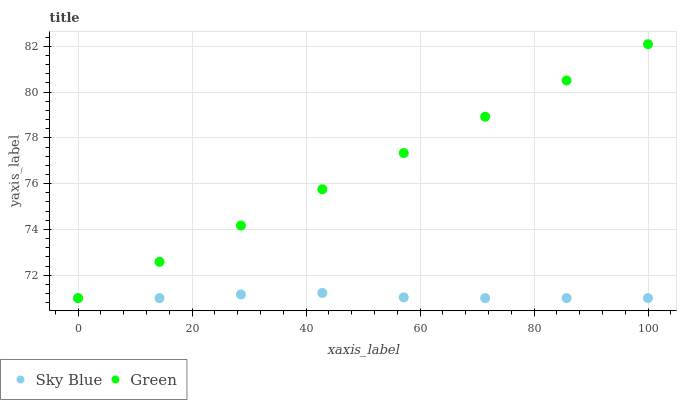Does Sky Blue have the minimum area under the curve?
Answer yes or no. Yes. Does Green have the maximum area under the curve?
Answer yes or no. Yes. Does Green have the minimum area under the curve?
Answer yes or no. No. Is Green the smoothest?
Answer yes or no. Yes. Is Sky Blue the roughest?
Answer yes or no. Yes. Is Green the roughest?
Answer yes or no. No. Does Sky Blue have the lowest value?
Answer yes or no. Yes. Does Green have the highest value?
Answer yes or no. Yes. Does Sky Blue intersect Green?
Answer yes or no. Yes. Is Sky Blue less than Green?
Answer yes or no. No. Is Sky Blue greater than Green?
Answer yes or no. No. 